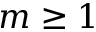<formula> <loc_0><loc_0><loc_500><loc_500>m \geq 1</formula> 